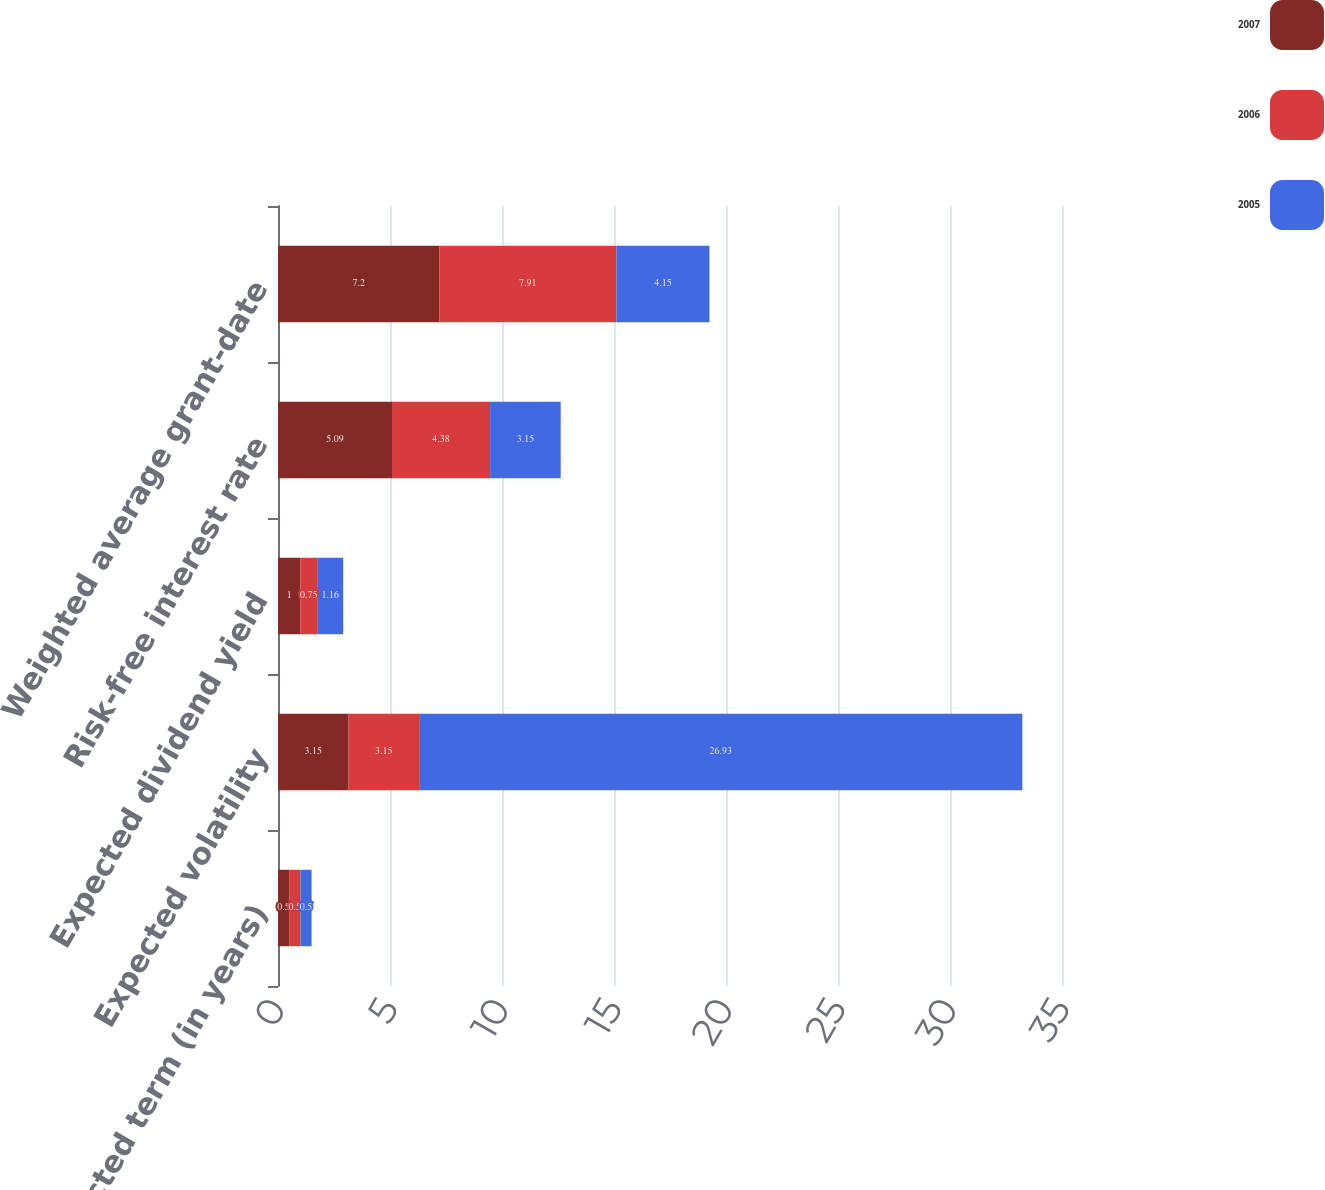Convert chart to OTSL. <chart><loc_0><loc_0><loc_500><loc_500><stacked_bar_chart><ecel><fcel>Expected term (in years)<fcel>Expected volatility<fcel>Expected dividend yield<fcel>Risk-free interest rate<fcel>Weighted average grant-date<nl><fcel>2007<fcel>0.5<fcel>3.15<fcel>1<fcel>5.09<fcel>7.2<nl><fcel>2006<fcel>0.5<fcel>3.15<fcel>0.75<fcel>4.38<fcel>7.91<nl><fcel>2005<fcel>0.5<fcel>26.93<fcel>1.16<fcel>3.15<fcel>4.15<nl></chart> 